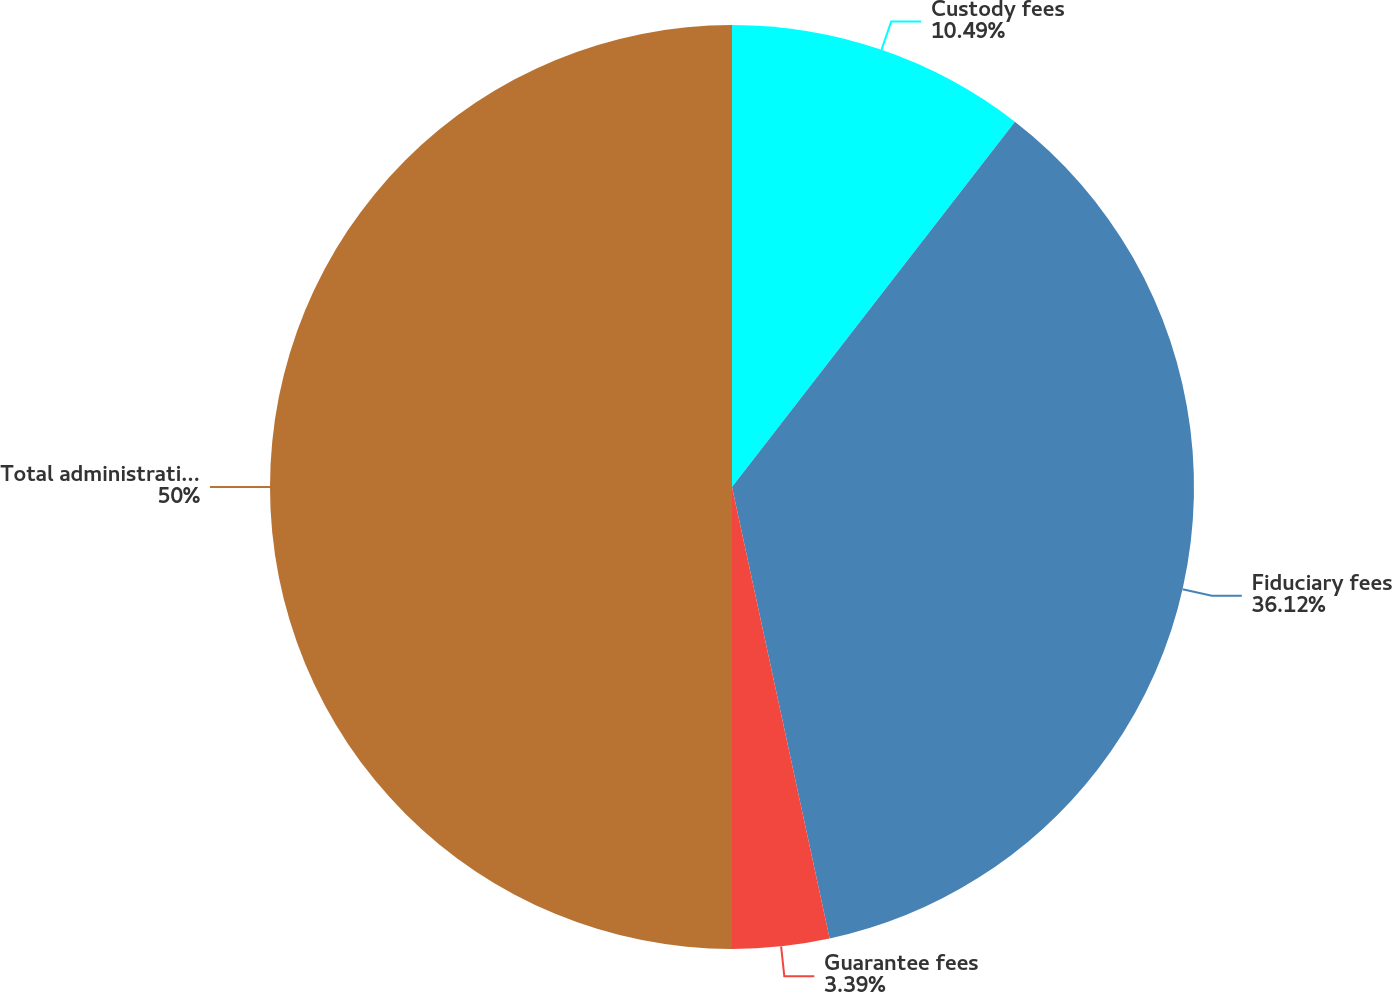Convert chart to OTSL. <chart><loc_0><loc_0><loc_500><loc_500><pie_chart><fcel>Custody fees<fcel>Fiduciary fees<fcel>Guarantee fees<fcel>Total administration and other<nl><fcel>10.49%<fcel>36.12%<fcel>3.39%<fcel>50.0%<nl></chart> 